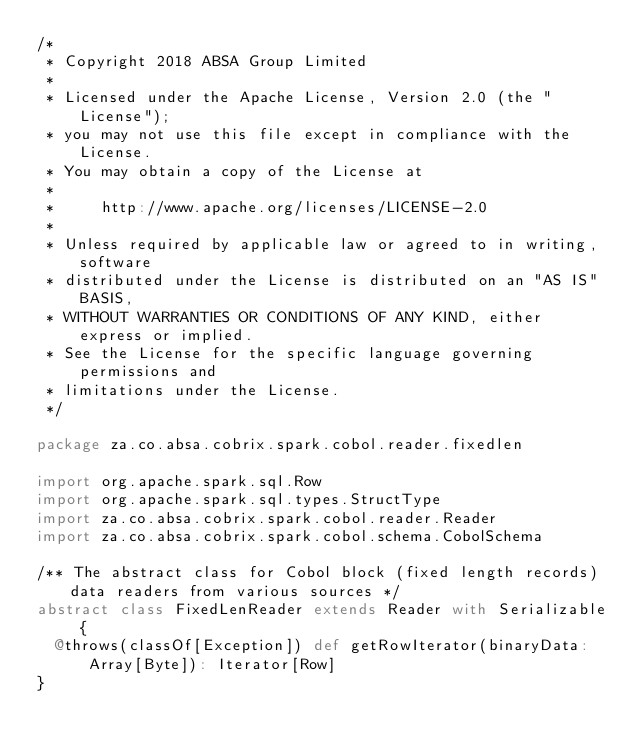Convert code to text. <code><loc_0><loc_0><loc_500><loc_500><_Scala_>/*
 * Copyright 2018 ABSA Group Limited
 *
 * Licensed under the Apache License, Version 2.0 (the "License");
 * you may not use this file except in compliance with the License.
 * You may obtain a copy of the License at
 *
 *     http://www.apache.org/licenses/LICENSE-2.0
 *
 * Unless required by applicable law or agreed to in writing, software
 * distributed under the License is distributed on an "AS IS" BASIS,
 * WITHOUT WARRANTIES OR CONDITIONS OF ANY KIND, either express or implied.
 * See the License for the specific language governing permissions and
 * limitations under the License.
 */

package za.co.absa.cobrix.spark.cobol.reader.fixedlen

import org.apache.spark.sql.Row
import org.apache.spark.sql.types.StructType
import za.co.absa.cobrix.spark.cobol.reader.Reader
import za.co.absa.cobrix.spark.cobol.schema.CobolSchema

/** The abstract class for Cobol block (fixed length records) data readers from various sources */
abstract class FixedLenReader extends Reader with Serializable {
  @throws(classOf[Exception]) def getRowIterator(binaryData: Array[Byte]): Iterator[Row]
}
</code> 